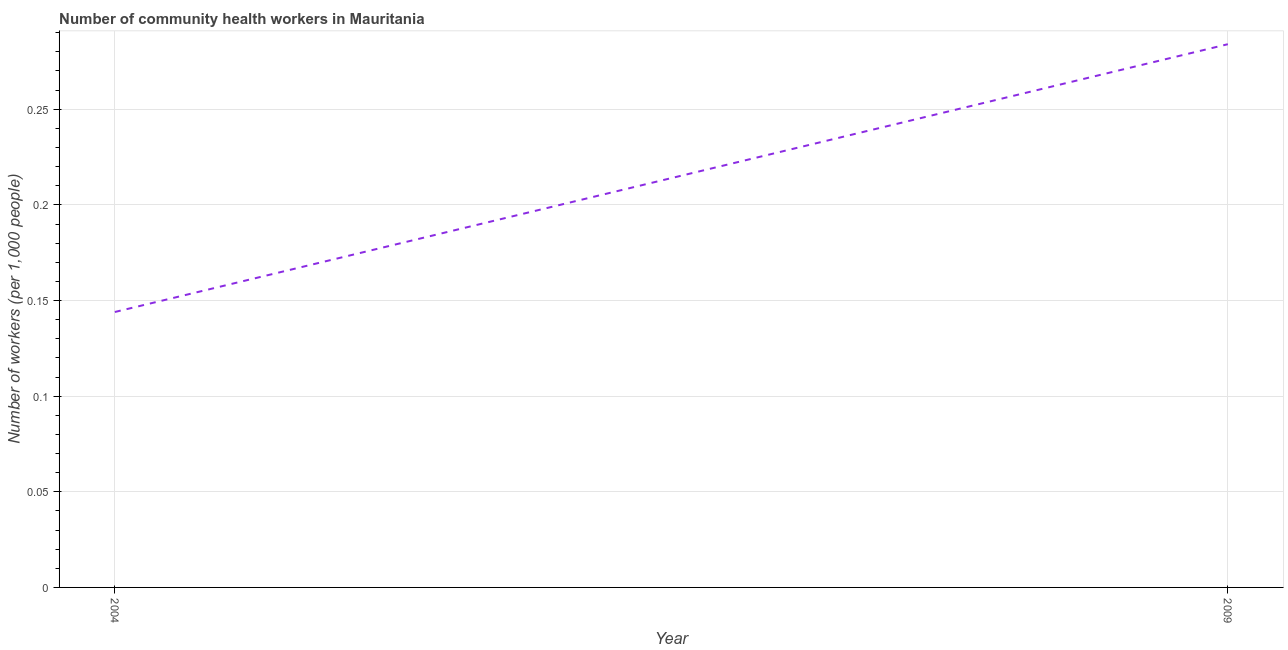What is the number of community health workers in 2009?
Ensure brevity in your answer.  0.28. Across all years, what is the maximum number of community health workers?
Provide a succinct answer. 0.28. Across all years, what is the minimum number of community health workers?
Your response must be concise. 0.14. What is the sum of the number of community health workers?
Offer a very short reply. 0.43. What is the difference between the number of community health workers in 2004 and 2009?
Your answer should be compact. -0.14. What is the average number of community health workers per year?
Offer a terse response. 0.21. What is the median number of community health workers?
Offer a terse response. 0.21. In how many years, is the number of community health workers greater than 0.09 ?
Your answer should be compact. 2. What is the ratio of the number of community health workers in 2004 to that in 2009?
Offer a terse response. 0.51. In how many years, is the number of community health workers greater than the average number of community health workers taken over all years?
Your answer should be very brief. 1. Does the number of community health workers monotonically increase over the years?
Make the answer very short. Yes. How many lines are there?
Offer a very short reply. 1. How many years are there in the graph?
Your answer should be very brief. 2. What is the difference between two consecutive major ticks on the Y-axis?
Make the answer very short. 0.05. Are the values on the major ticks of Y-axis written in scientific E-notation?
Your answer should be compact. No. Does the graph contain grids?
Make the answer very short. Yes. What is the title of the graph?
Keep it short and to the point. Number of community health workers in Mauritania. What is the label or title of the Y-axis?
Keep it short and to the point. Number of workers (per 1,0 people). What is the Number of workers (per 1,000 people) in 2004?
Provide a short and direct response. 0.14. What is the Number of workers (per 1,000 people) in 2009?
Make the answer very short. 0.28. What is the difference between the Number of workers (per 1,000 people) in 2004 and 2009?
Your answer should be compact. -0.14. What is the ratio of the Number of workers (per 1,000 people) in 2004 to that in 2009?
Give a very brief answer. 0.51. 